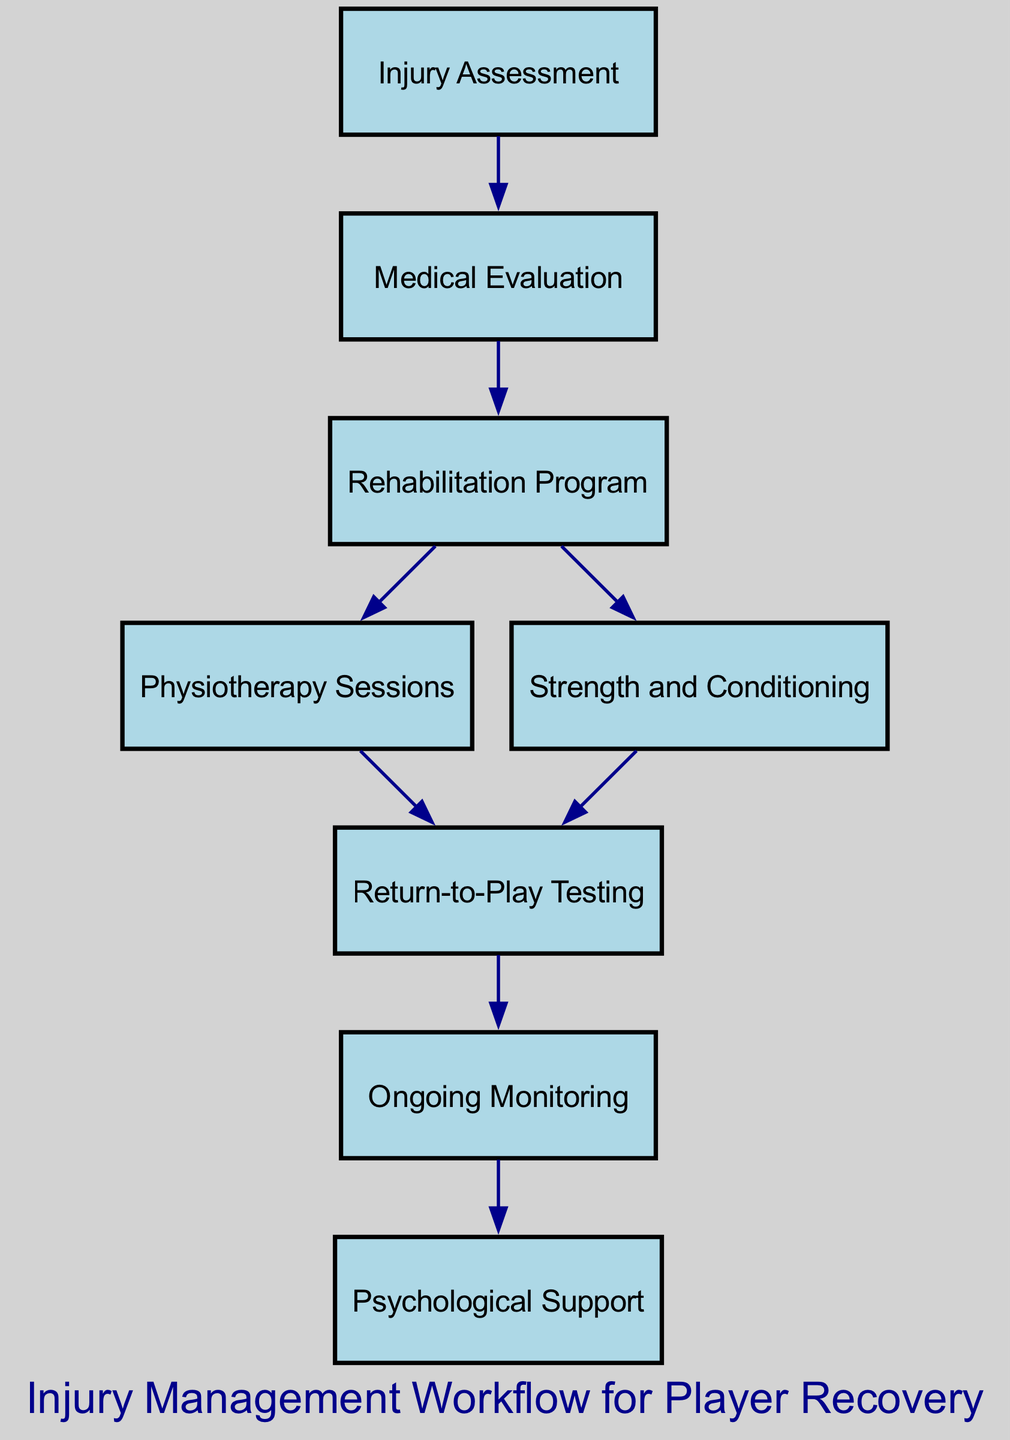What is the starting point of the injury management workflow? The starting point is the "Injury Assessment", as it is the first node in the directed graph.
Answer: Injury Assessment How many steps are in the rehabilitation program? The rehabilitation program refers to the "Rehabilitation Program", which leads to "Physiotherapy Sessions" and "Strength and Conditioning", indicating there are 2 steps.
Answer: 2 steps Which node follows the "Medical Evaluation"? The "Medical Evaluation" leads directly to the "Rehabilitation Program", making it the next node in the queue.
Answer: Rehabilitation Program What is the last step in the workflow? The last step in the workflow is "Psychological Support", as it is the end node that follows "Ongoing Monitoring".
Answer: Psychological Support How many total nodes are present in the diagram? By counting all the unique labels represented by nodes, we find there are 8 distinct nodes in total.
Answer: 8 What are the two outcomes of the "Rehabilitation Program"? The "Rehabilitation Program" connects to "Physiotherapy Sessions" and "Strength and Conditioning", representing its two outcomes or paths.
Answer: Physiotherapy Sessions and Strength and Conditioning Which two nodes lead to "Return-to-Play Testing"? The nodes that lead to "Return-to-Play Testing" are "Physiotherapy Sessions" and "Strength and Conditioning", showing the paths taken prior to testing.
Answer: Physiotherapy Sessions and Strength and Conditioning What is the relationship between "Ongoing Monitoring" and "Psychological Support"? "Ongoing Monitoring" flows directly into "Psychological Support", indicating that ongoing monitoring informs the need for psychological support.
Answer: Ongoing Monitoring into Psychological Support Which step comes before "Return-to-Play Testing"? The nodes directly before "Return-to-Play Testing" are "Physiotherapy Sessions" and "Strength and Conditioning", which are the last key activities before testing.
Answer: Physiotherapy Sessions and Strength and Conditioning What is the first node to initiate the player recovery process? The first node that initiates the player recovery process is "Injury Assessment", marking the starting point of the workflow.
Answer: Injury Assessment 